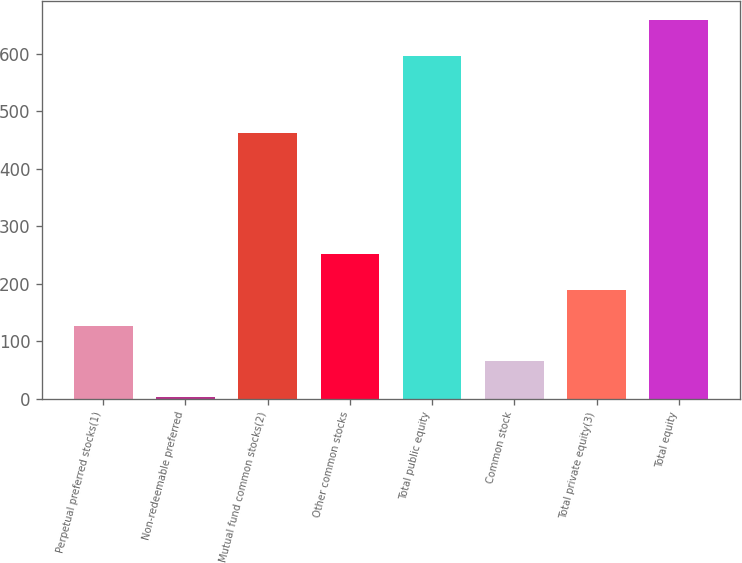Convert chart. <chart><loc_0><loc_0><loc_500><loc_500><bar_chart><fcel>Perpetual preferred stocks(1)<fcel>Non-redeemable preferred<fcel>Mutual fund common stocks(2)<fcel>Other common stocks<fcel>Total public equity<fcel>Common stock<fcel>Total private equity(3)<fcel>Total equity<nl><fcel>127.6<fcel>4<fcel>462<fcel>251.2<fcel>597<fcel>65.8<fcel>189.4<fcel>658.8<nl></chart> 